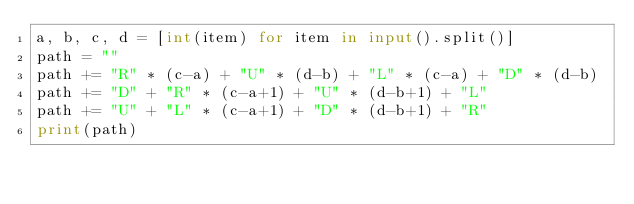<code> <loc_0><loc_0><loc_500><loc_500><_Python_>a, b, c, d = [int(item) for item in input().split()]
path = ""
path += "R" * (c-a) + "U" * (d-b) + "L" * (c-a) + "D" * (d-b)
path += "D" + "R" * (c-a+1) + "U" * (d-b+1) + "L"
path += "U" + "L" * (c-a+1) + "D" * (d-b+1) + "R"
print(path)</code> 